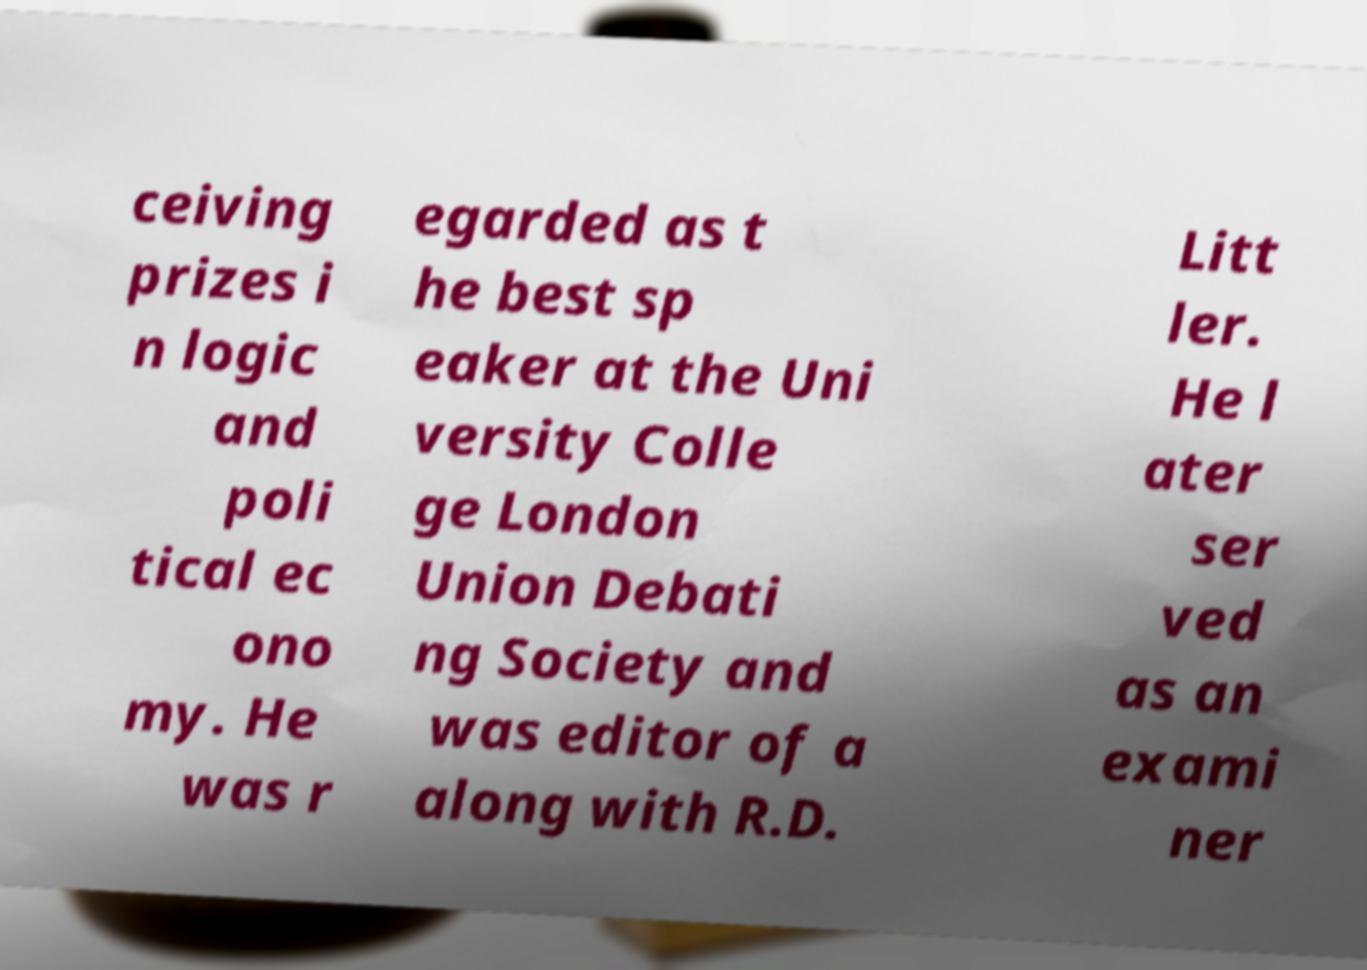Please identify and transcribe the text found in this image. ceiving prizes i n logic and poli tical ec ono my. He was r egarded as t he best sp eaker at the Uni versity Colle ge London Union Debati ng Society and was editor of a along with R.D. Litt ler. He l ater ser ved as an exami ner 